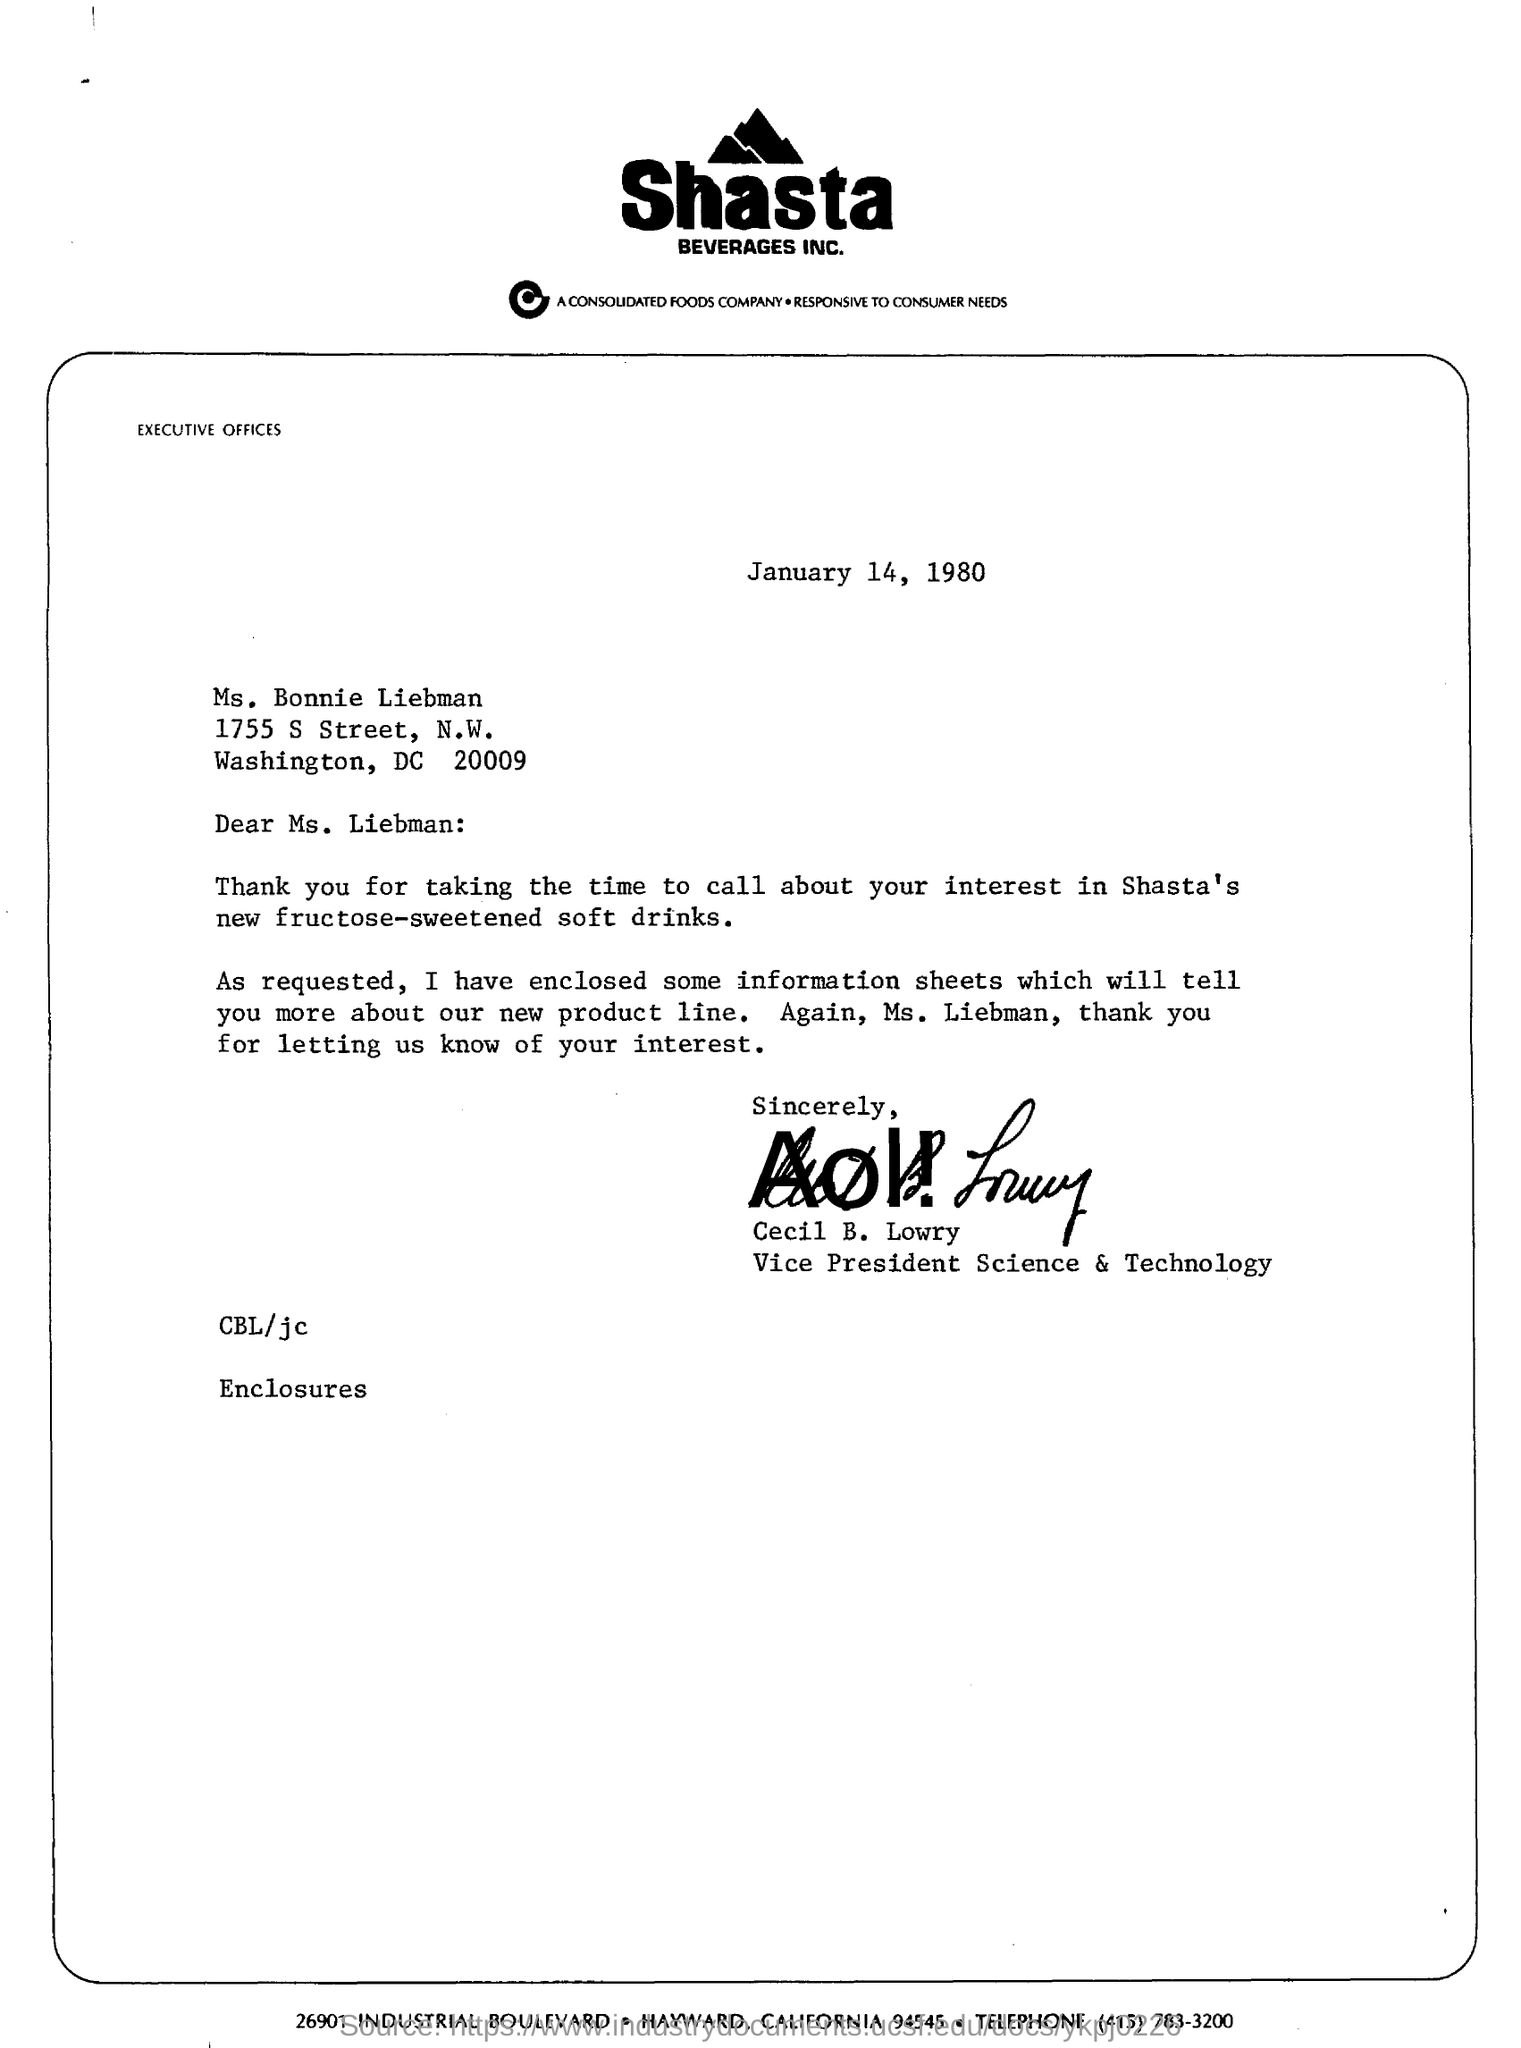Whats the name of company ?
Make the answer very short. Shasta Beverages Inc. Who is this letter sent to ?
Provide a succinct answer. Ms. Liebman. Who is the vice president of shasta beverages?
Your answer should be compact. Cecil B. Lowry. What is the date mentioned in this letter?
Make the answer very short. January 14, 1980. 